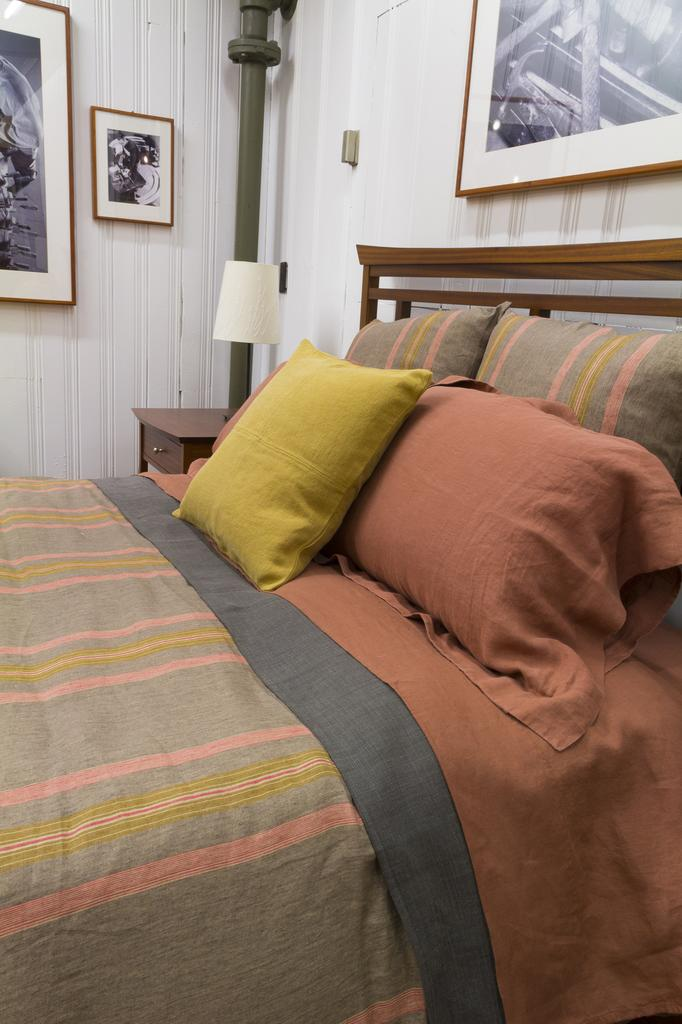What is hanging on the wall in the image? There are photo frames on a wall in the image. What is on the table in the image? There is a lamp on a table in the image. What type of furniture is in the image? There is a bed in the image. What is on the bed in the image? The bed has pillows and a blanket. What direction is the jam facing in the image? There is no jam present in the image. What type of material is the steel bed made of in the image? There is no steel bed present in the image; the bed has pillows and a blanket, but no specific material is mentioned. 